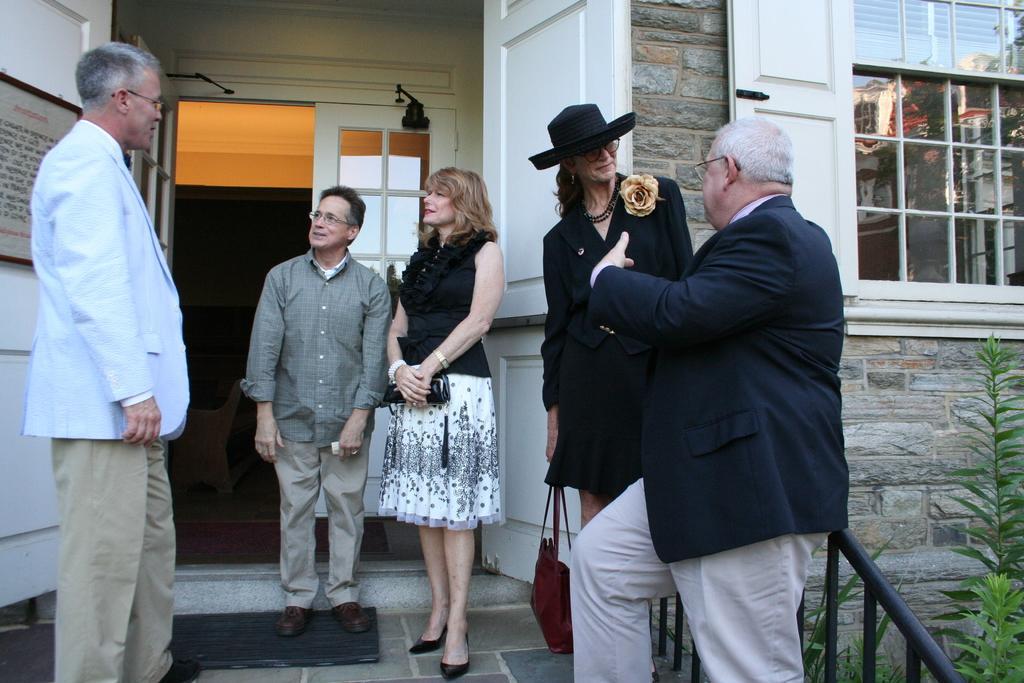How would you summarize this image in a sentence or two? In this image there are few people who are standing one beside the other and talking with each other. In the background there is a building. On the right side there is a window. In the middle there is a door. On the right side bottom there are plants. At the bottom there is mat. 